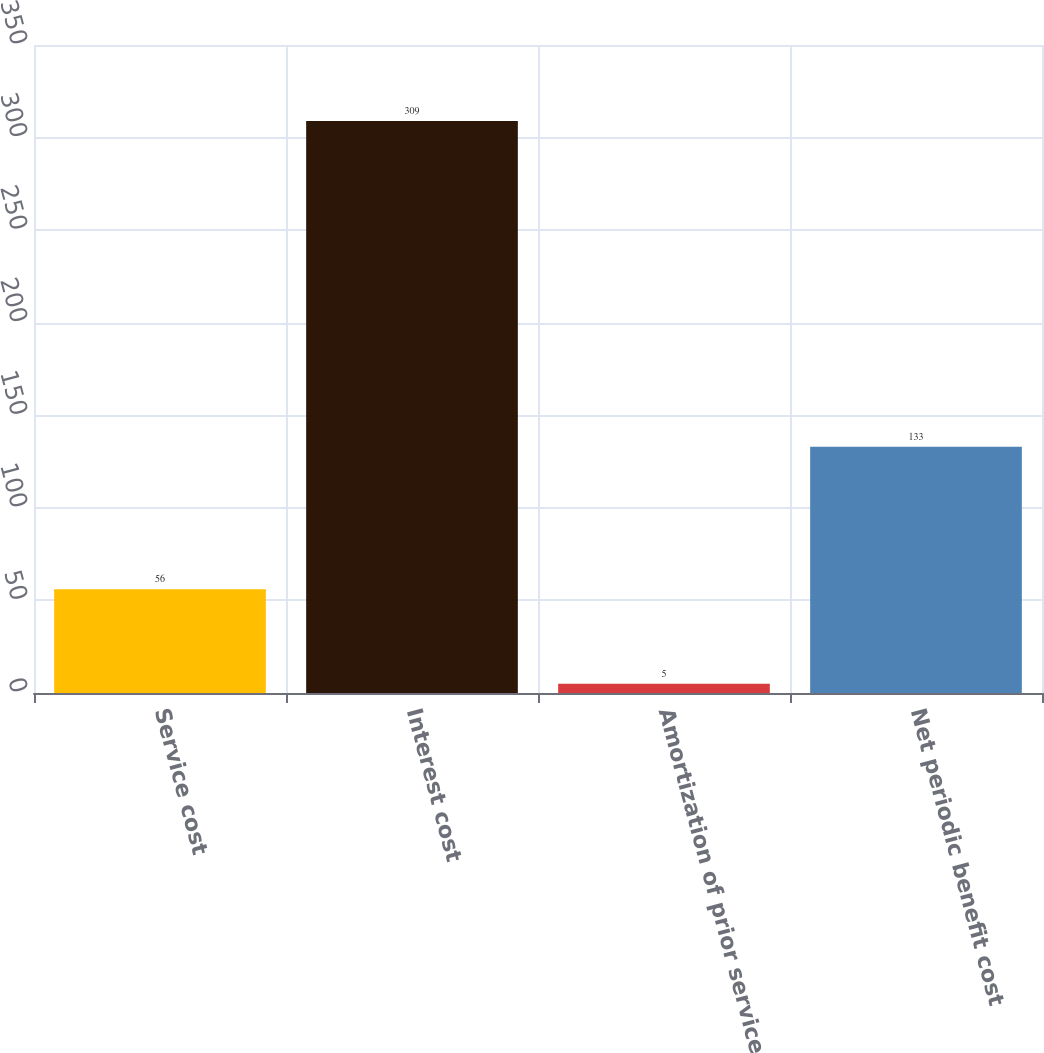<chart> <loc_0><loc_0><loc_500><loc_500><bar_chart><fcel>Service cost<fcel>Interest cost<fcel>Amortization of prior service<fcel>Net periodic benefit cost<nl><fcel>56<fcel>309<fcel>5<fcel>133<nl></chart> 